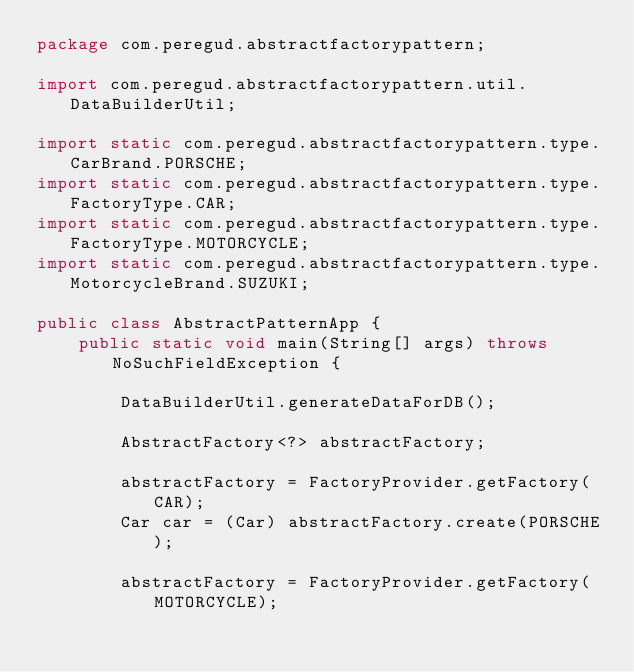Convert code to text. <code><loc_0><loc_0><loc_500><loc_500><_Java_>package com.peregud.abstractfactorypattern;

import com.peregud.abstractfactorypattern.util.DataBuilderUtil;

import static com.peregud.abstractfactorypattern.type.CarBrand.PORSCHE;
import static com.peregud.abstractfactorypattern.type.FactoryType.CAR;
import static com.peregud.abstractfactorypattern.type.FactoryType.MOTORCYCLE;
import static com.peregud.abstractfactorypattern.type.MotorcycleBrand.SUZUKI;

public class AbstractPatternApp {
    public static void main(String[] args) throws NoSuchFieldException {

        DataBuilderUtil.generateDataForDB();

        AbstractFactory<?> abstractFactory;

        abstractFactory = FactoryProvider.getFactory(CAR);
        Car car = (Car) abstractFactory.create(PORSCHE);

        abstractFactory = FactoryProvider.getFactory(MOTORCYCLE);</code> 